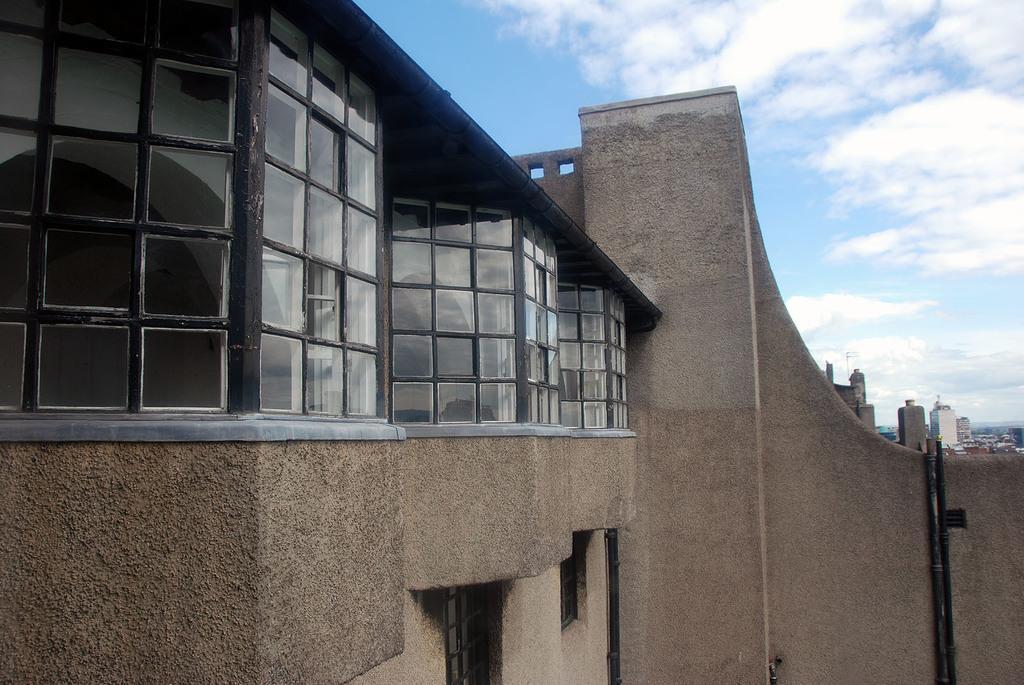Please provide a concise description of this image. In this picture we can see the buildings, wall, pole, windows, pipes. At the top of the image we can see the clouds are present in the sky. 